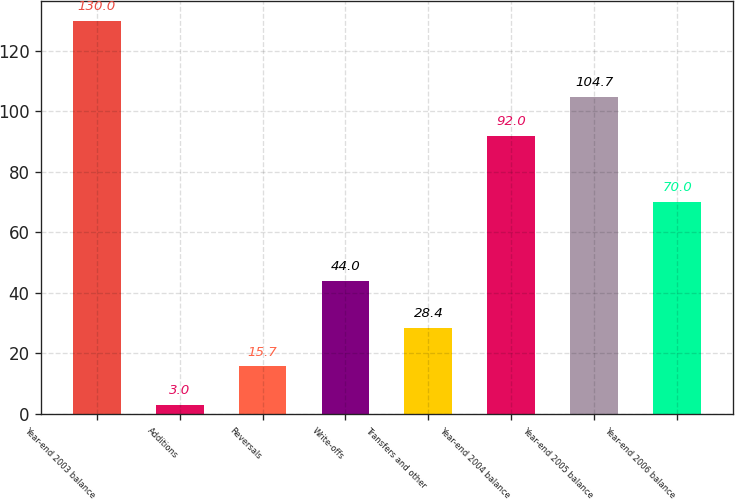Convert chart to OTSL. <chart><loc_0><loc_0><loc_500><loc_500><bar_chart><fcel>Year-end 2003 balance<fcel>Additions<fcel>Reversals<fcel>Write-offs<fcel>Transfers and other<fcel>Year-end 2004 balance<fcel>Year-end 2005 balance<fcel>Year-end 2006 balance<nl><fcel>130<fcel>3<fcel>15.7<fcel>44<fcel>28.4<fcel>92<fcel>104.7<fcel>70<nl></chart> 